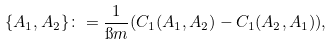<formula> <loc_0><loc_0><loc_500><loc_500>\{ A _ { 1 } , A _ { 2 } \} \colon = \frac { 1 } { \i m } ( C _ { 1 } ( A _ { 1 } , A _ { 2 } ) - C _ { 1 } ( A _ { 2 } , A _ { 1 } ) ) ,</formula> 